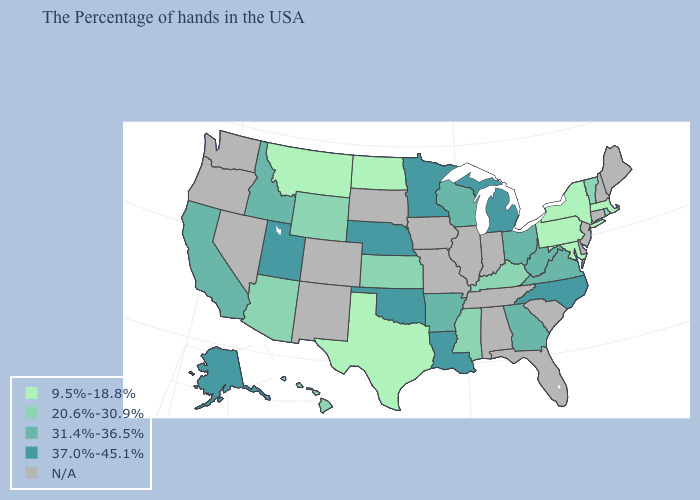What is the value of Hawaii?
Concise answer only. 20.6%-30.9%. What is the value of Nebraska?
Short answer required. 37.0%-45.1%. Which states have the lowest value in the South?
Give a very brief answer. Maryland, Texas. Among the states that border Wyoming , does Montana have the lowest value?
Concise answer only. Yes. How many symbols are there in the legend?
Give a very brief answer. 5. Which states have the highest value in the USA?
Keep it brief. North Carolina, Michigan, Louisiana, Minnesota, Nebraska, Oklahoma, Utah, Alaska. Does the first symbol in the legend represent the smallest category?
Give a very brief answer. Yes. Name the states that have a value in the range 31.4%-36.5%?
Quick response, please. Virginia, West Virginia, Ohio, Georgia, Wisconsin, Arkansas, Idaho, California. Does Kentucky have the lowest value in the South?
Quick response, please. No. What is the value of Virginia?
Concise answer only. 31.4%-36.5%. What is the lowest value in states that border North Carolina?
Be succinct. 31.4%-36.5%. Name the states that have a value in the range 37.0%-45.1%?
Concise answer only. North Carolina, Michigan, Louisiana, Minnesota, Nebraska, Oklahoma, Utah, Alaska. What is the value of Vermont?
Be succinct. 20.6%-30.9%. What is the value of Oregon?
Short answer required. N/A. 